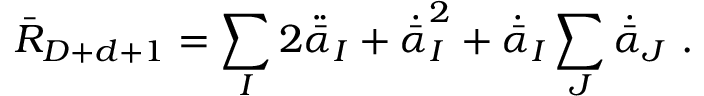Convert formula to latex. <formula><loc_0><loc_0><loc_500><loc_500>\bar { R } _ { D + d + 1 } = \sum _ { I } 2 \ddot { \bar { \alpha } } _ { I } + \dot { \bar { \alpha } } _ { I } ^ { 2 } + \dot { \bar { \alpha } } _ { I } \sum _ { J } \dot { \bar { \alpha } } _ { J } \ .</formula> 